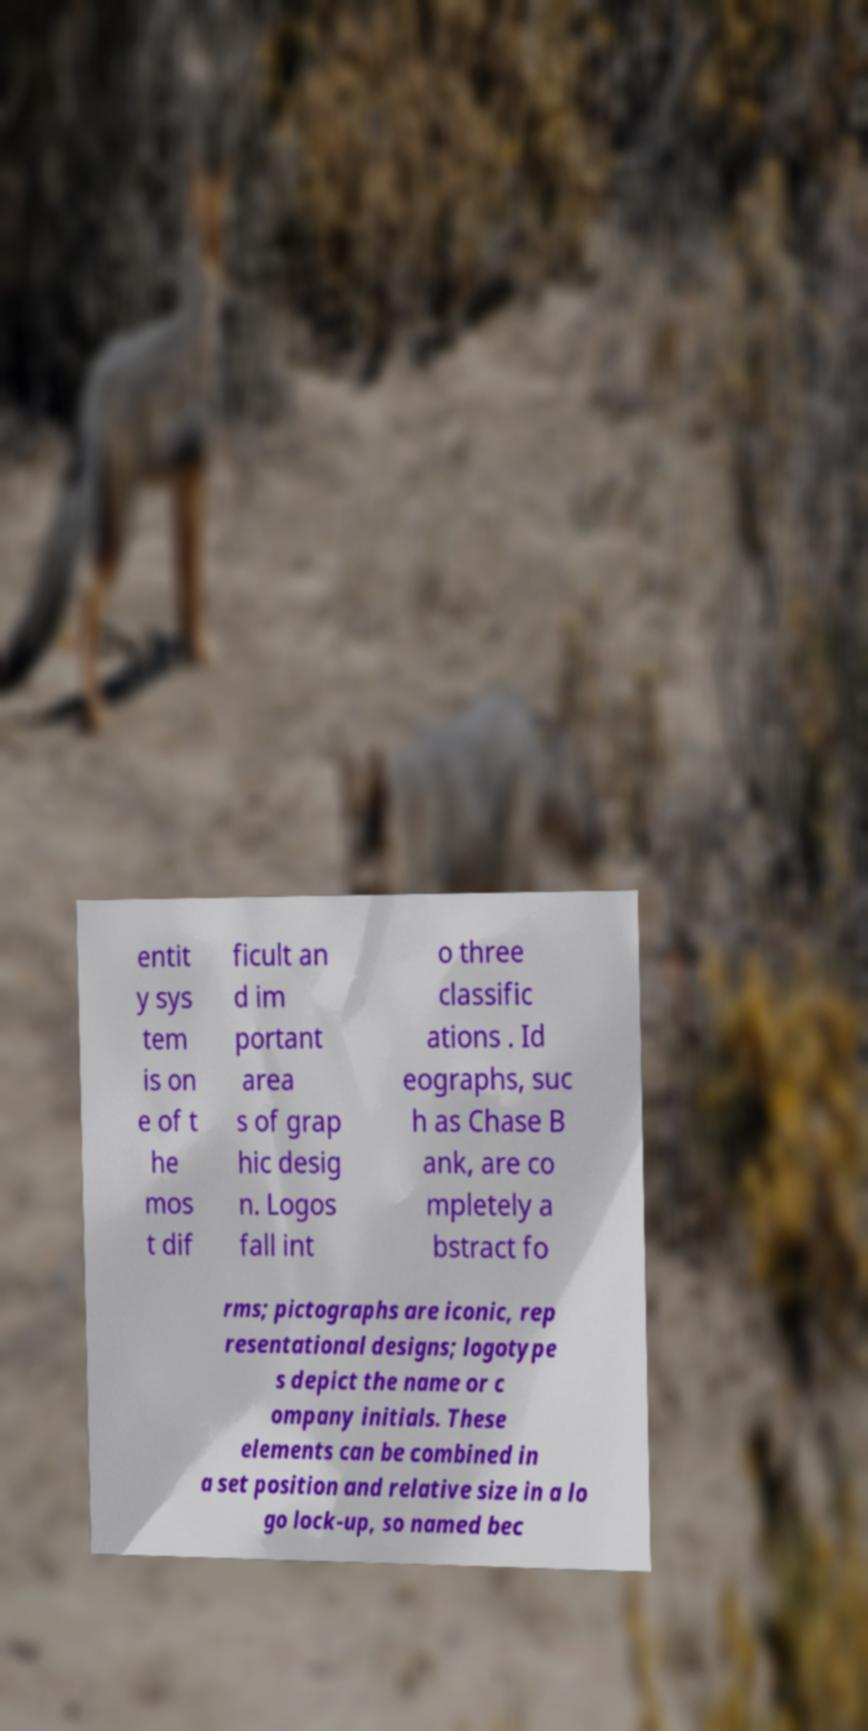Can you read and provide the text displayed in the image?This photo seems to have some interesting text. Can you extract and type it out for me? entit y sys tem is on e of t he mos t dif ficult an d im portant area s of grap hic desig n. Logos fall int o three classific ations . Id eographs, suc h as Chase B ank, are co mpletely a bstract fo rms; pictographs are iconic, rep resentational designs; logotype s depict the name or c ompany initials. These elements can be combined in a set position and relative size in a lo go lock-up, so named bec 